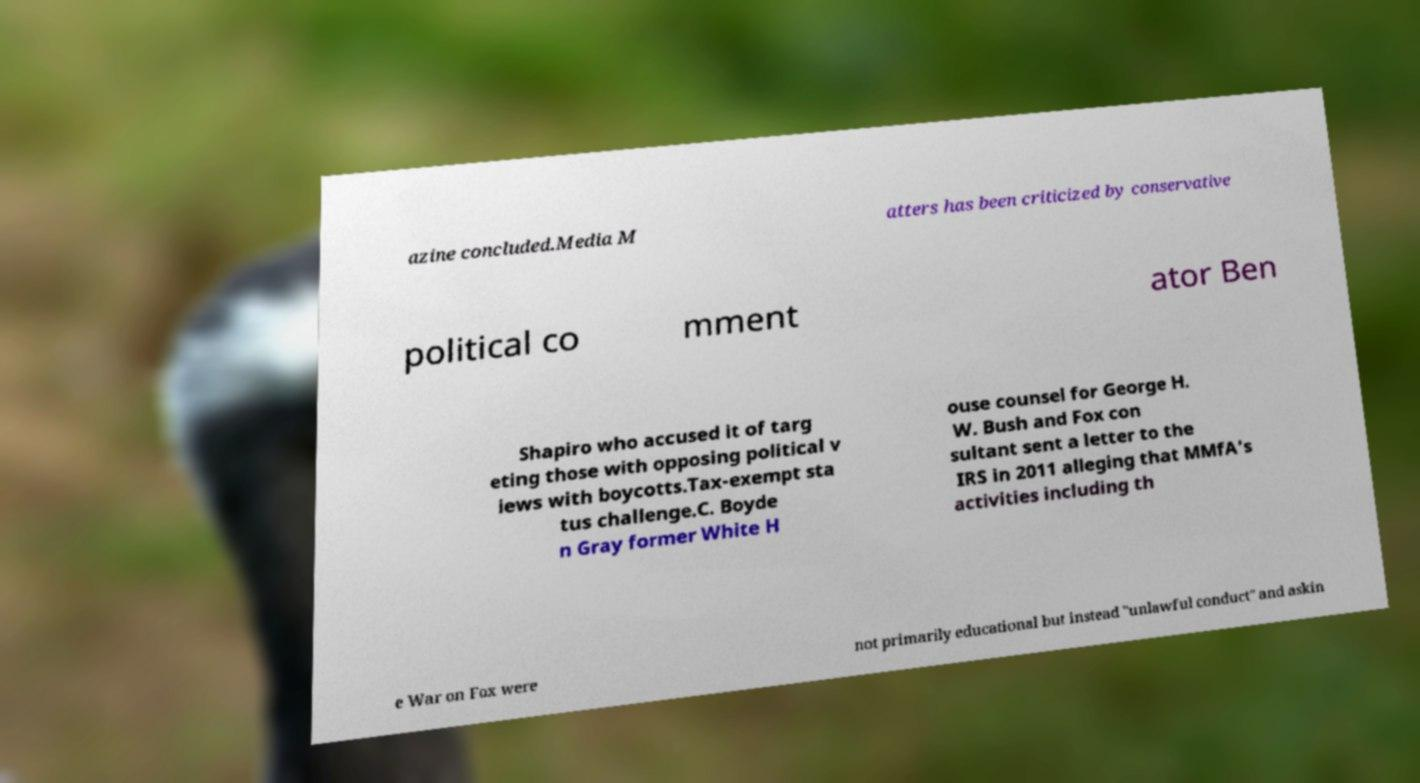What messages or text are displayed in this image? I need them in a readable, typed format. azine concluded.Media M atters has been criticized by conservative political co mment ator Ben Shapiro who accused it of targ eting those with opposing political v iews with boycotts.Tax-exempt sta tus challenge.C. Boyde n Gray former White H ouse counsel for George H. W. Bush and Fox con sultant sent a letter to the IRS in 2011 alleging that MMfA's activities including th e War on Fox were not primarily educational but instead "unlawful conduct" and askin 